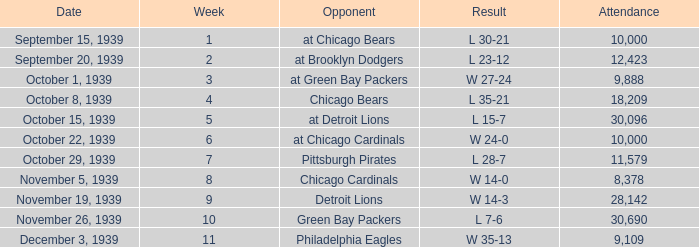What sum of Attendance has a Week smaller than 10, and a Result of l 30-21? 10000.0. 